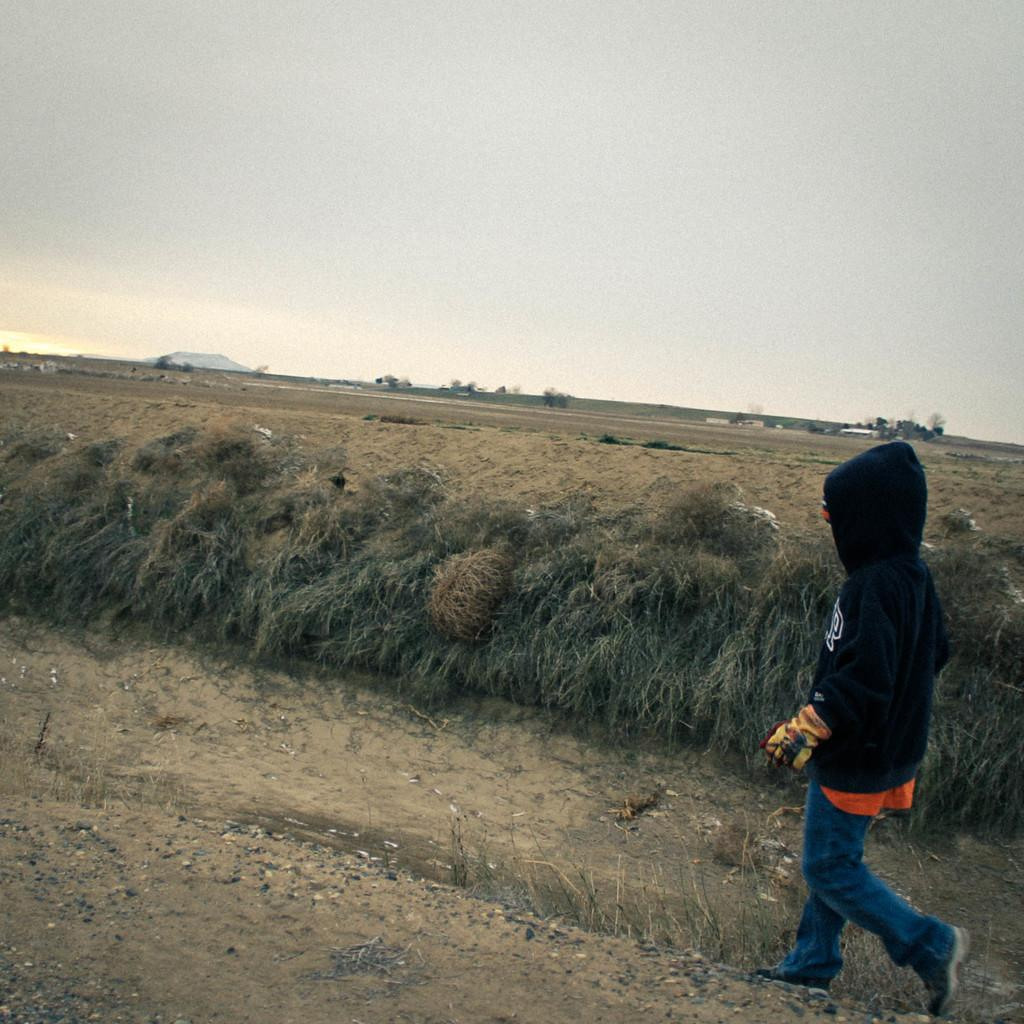What is the main subject of the image? There is a person walking in the image. What type of vegetation can be seen in the image? There is grass stock visible in the image. What is visible in the background of the image? There are trees in the background of the image. What is visible at the top of the image? The sky is visible at the top of the image. What type of test is being conducted in the image? There is no test being conducted in the image; it features a person walking in a natural setting. Can you see an airplane in the image? No, there is no airplane present in the image. 